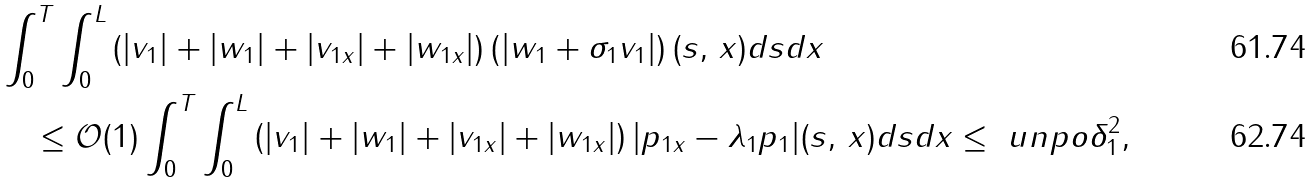Convert formula to latex. <formula><loc_0><loc_0><loc_500><loc_500>& \int _ { 0 } ^ { T } \int _ { 0 } ^ { L } \left ( | v _ { 1 } | + | w _ { 1 } | + | v _ { 1 x } | + | w _ { 1 x } | \right ) \left ( | w _ { 1 } + \sigma _ { 1 } v _ { 1 } | \right ) ( s , \, x ) d s d x \\ & \quad \leq \mathcal { O } ( 1 ) \int _ { 0 } ^ { T } \int _ { 0 } ^ { L } \left ( | v _ { 1 } | + | w _ { 1 } | + | v _ { 1 x } | + | w _ { 1 x } | \right ) | p _ { 1 x } - \lambda _ { 1 } p _ { 1 } | ( s , \, x ) d s d x \leq \ u n p o \delta _ { 1 } ^ { 2 } ,</formula> 